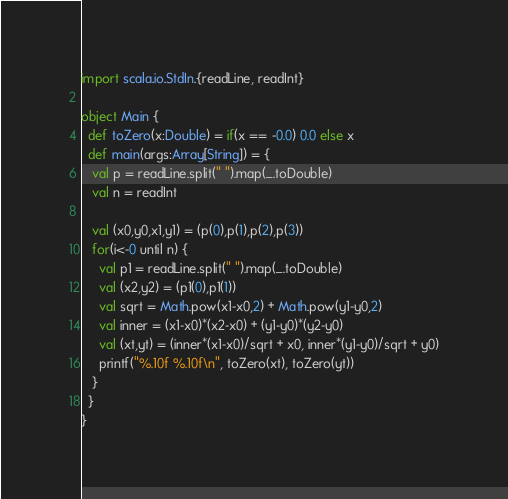Convert code to text. <code><loc_0><loc_0><loc_500><loc_500><_Scala_>import scala.io.StdIn.{readLine, readInt}
  
object Main {
  def toZero(x:Double) = if(x == -0.0) 0.0 else x
  def main(args:Array[String]) = {
   val p = readLine.split(" ").map(_.toDouble)
   val n = readInt

   val (x0,y0,x1,y1) = (p(0),p(1),p(2),p(3))
   for(i<-0 until n) {
     val p1 = readLine.split(" ").map(_.toDouble)
     val (x2,y2) = (p1(0),p1(1))
     val sqrt = Math.pow(x1-x0,2) + Math.pow(y1-y0,2)
     val inner = (x1-x0)*(x2-x0) + (y1-y0)*(y2-y0)
     val (xt,yt) = (inner*(x1-x0)/sqrt + x0, inner*(y1-y0)/sqrt + y0)
     printf("%.10f %.10f\n", toZero(xt), toZero(yt))
   }
  }
}</code> 